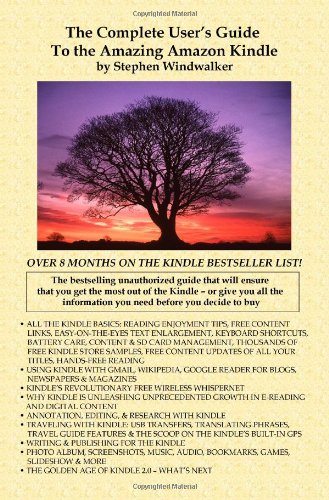What is the genre of this book? The genre of 'The Complete User's Guide to the Amazing Amazon Kindle (First Generation)' falls under Computers & Technology, focusing on the technical aspects and user features of the Kindle device. 